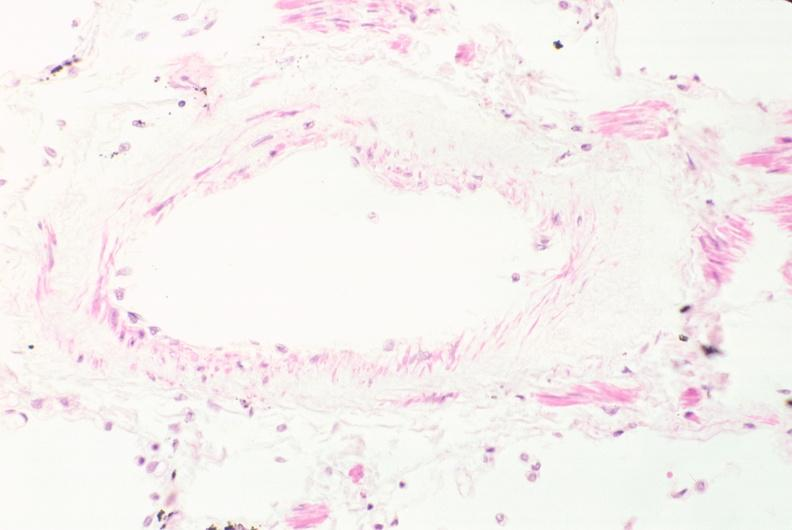what does this image show?
Answer the question using a single word or phrase. Lung 